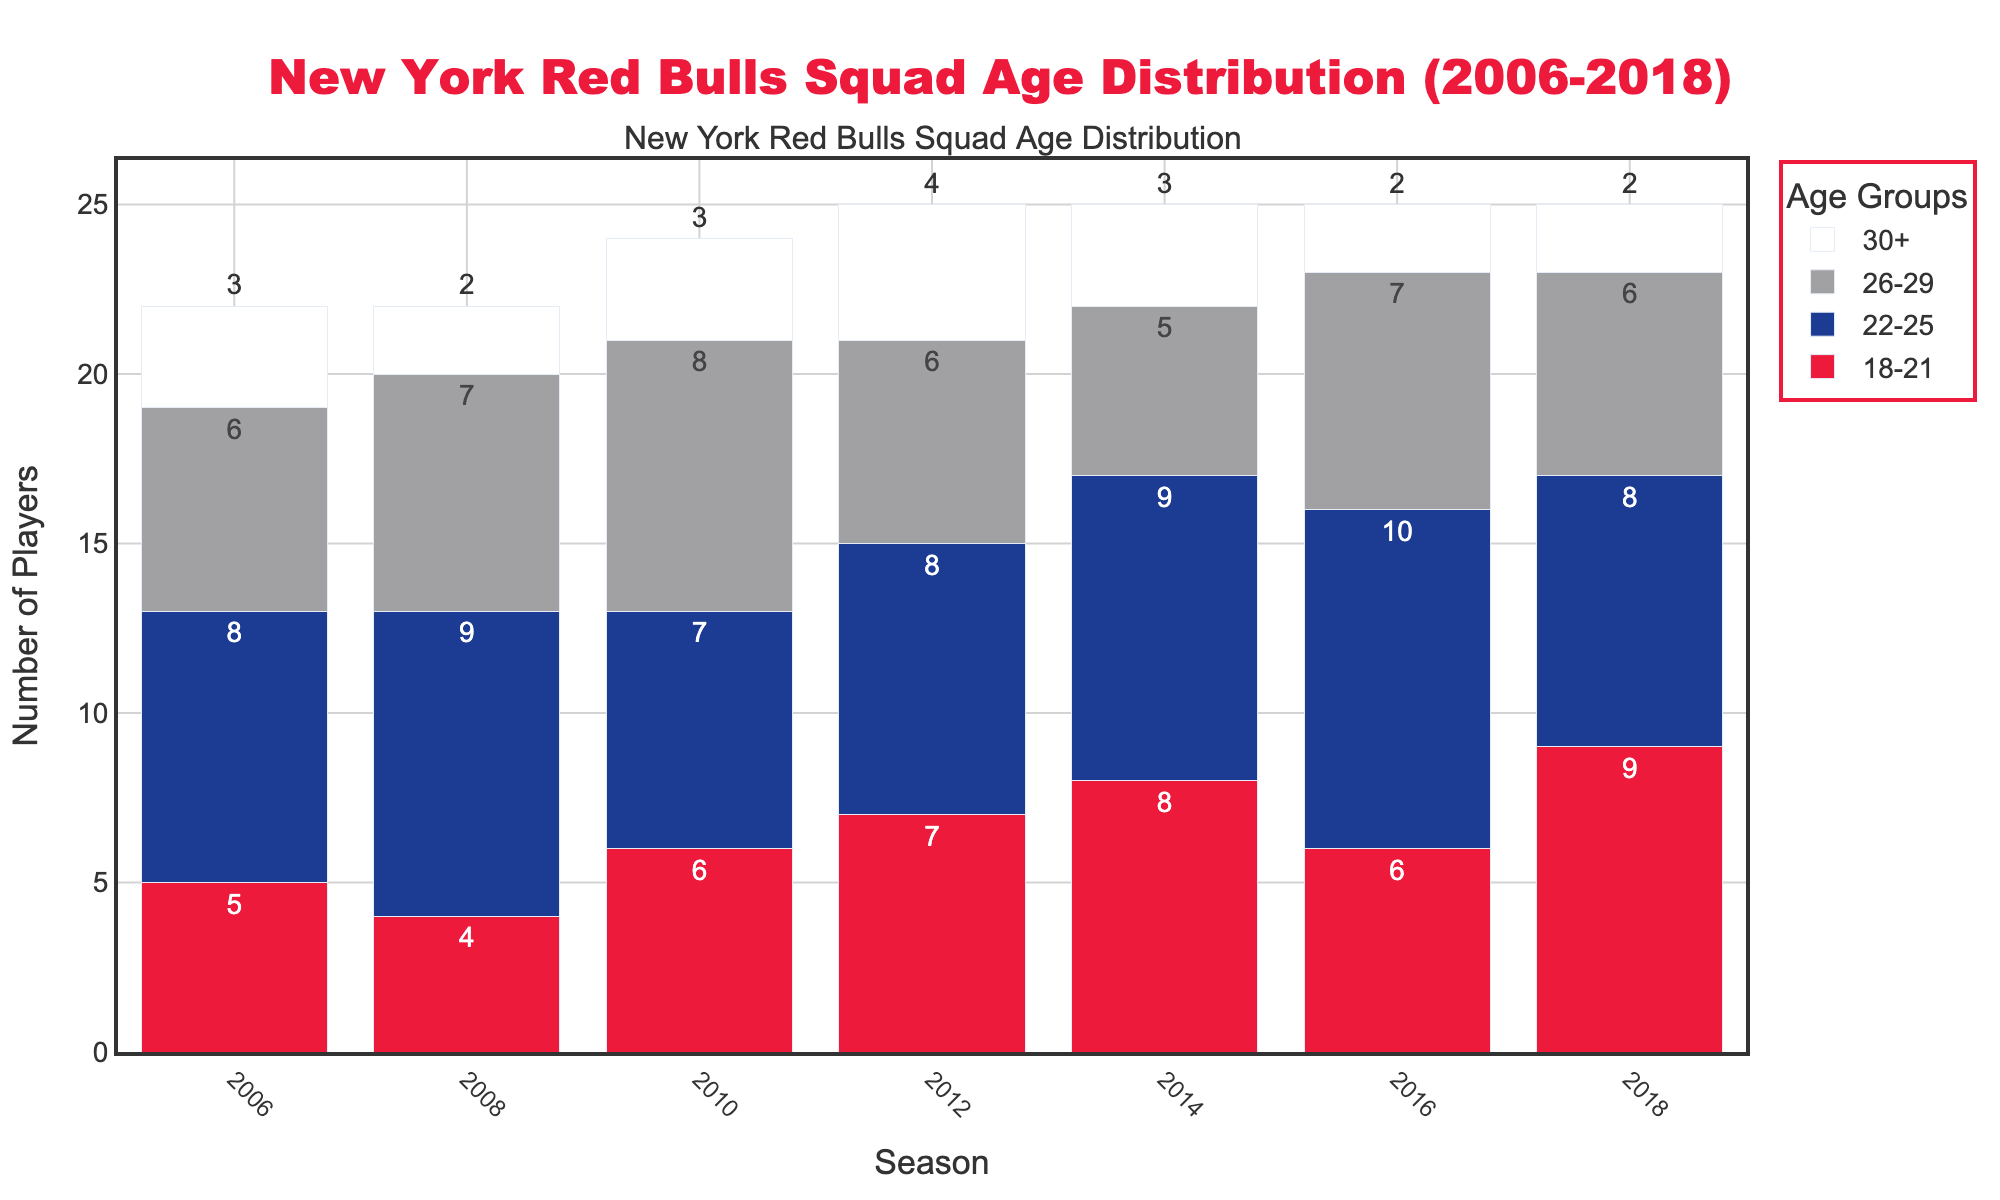What's the largest age group of players in the 2006 season? By looking at the bar heights in the 2006 season, we compare the bars for each age group. The highest bar is for the age group 22-25.
Answer: 22-25 Which season had the highest number of players aged 18-21? By comparing the heights of the red bars representing the age group 18-21, we see that the highest red bar is in 2018.
Answer: 2018 How did the number of players aged 30+ change between 2006 and 2018? The count of players aged 30+ decreased from 3 in 2006 to 2 in 2018.
Answer: Decreased by 1 In which season did the number of players aged 26-29 peak? By comparing the heights of the bars across seasons, the highest bar for the 26-29 age group is in 2010.
Answer: 2010 What's the total number of players in the squad for the 2016 season? Summing the heights of all bars for the 2016 season: 6 (18-21) + 10 (22-25) + 7 (26-29) + 2 (30+) = 25.
Answer: 25 In which season were the players most evenly distributed across the age groups? By looking at the relative similarities in bar heights across all age groups, the bars in 2008 are more evenly distributed.
Answer: 2008 Which age group had the most significant increase from 2006 to 2014? Calculating the difference in heights from 2006 to 2014: (18-21: +3, 22-25: +1, 26-29: -1, 30+: 0). Here, 18-21 had the most significant increase.
Answer: 18-21 Between the seasons 2010 and 2012, did the number of players aged 22-25 go up or down? Comparing the bar heights, the number of players aged 22-25 went from 7 in 2010 to 8 in 2012.
Answer: Up by 1 For which seasons did the number of players aged 26-29 remain the same? By comparing the bar heights, the count for the 26-29 age group is the same (6 players) in 2006 and 2012.
Answer: 2006 and 2012 